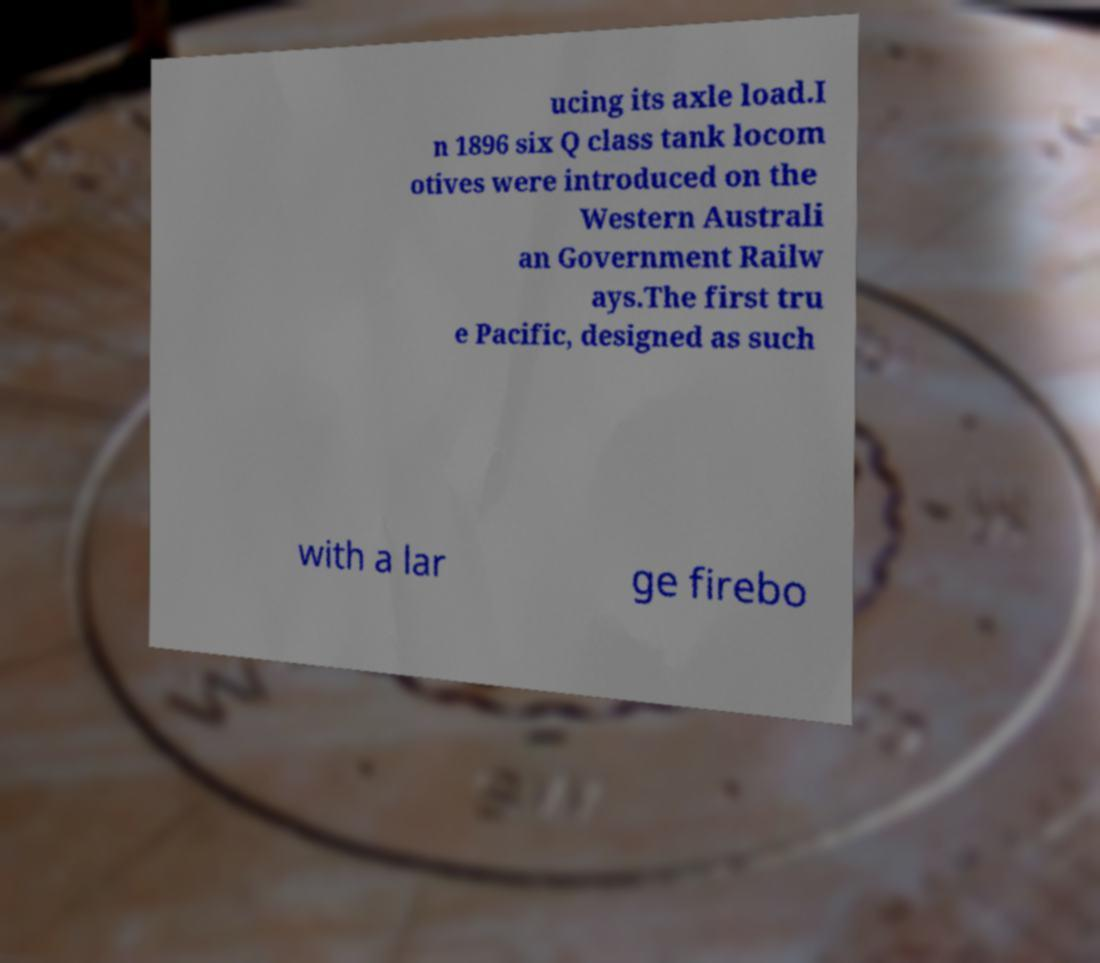I need the written content from this picture converted into text. Can you do that? ucing its axle load.I n 1896 six Q class tank locom otives were introduced on the Western Australi an Government Railw ays.The first tru e Pacific, designed as such with a lar ge firebo 